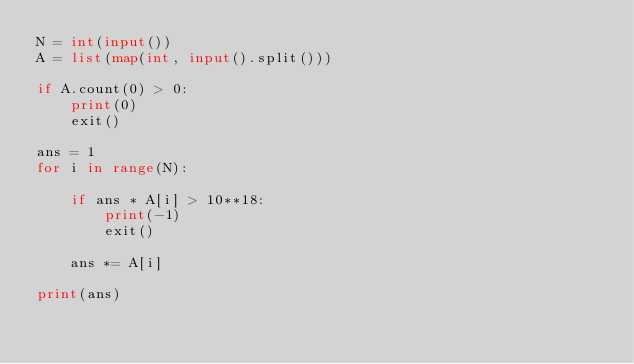Convert code to text. <code><loc_0><loc_0><loc_500><loc_500><_Python_>N = int(input())
A = list(map(int, input().split()))

if A.count(0) > 0:
    print(0)
    exit()

ans = 1
for i in range(N):

    if ans * A[i] > 10**18:
        print(-1)
        exit()

    ans *= A[i]

print(ans)
</code> 